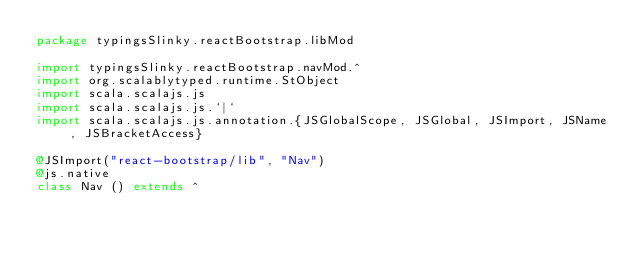Convert code to text. <code><loc_0><loc_0><loc_500><loc_500><_Scala_>package typingsSlinky.reactBootstrap.libMod

import typingsSlinky.reactBootstrap.navMod.^
import org.scalablytyped.runtime.StObject
import scala.scalajs.js
import scala.scalajs.js.`|`
import scala.scalajs.js.annotation.{JSGlobalScope, JSGlobal, JSImport, JSName, JSBracketAccess}

@JSImport("react-bootstrap/lib", "Nav")
@js.native
class Nav () extends ^
</code> 